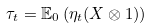Convert formula to latex. <formula><loc_0><loc_0><loc_500><loc_500>\tau _ { t } = \mathbb { E } _ { 0 } \left ( \eta _ { t } ( X \otimes 1 ) \right )</formula> 